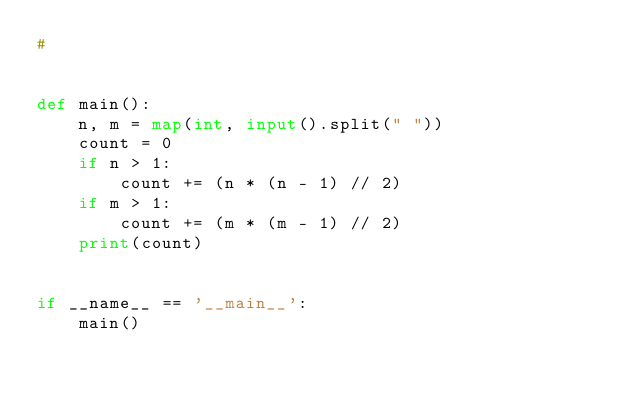Convert code to text. <code><loc_0><loc_0><loc_500><loc_500><_Python_>#


def main():
    n, m = map(int, input().split(" "))
    count = 0
    if n > 1:
        count += (n * (n - 1) // 2)
    if m > 1:
        count += (m * (m - 1) // 2)
    print(count)


if __name__ == '__main__':
    main()
</code> 